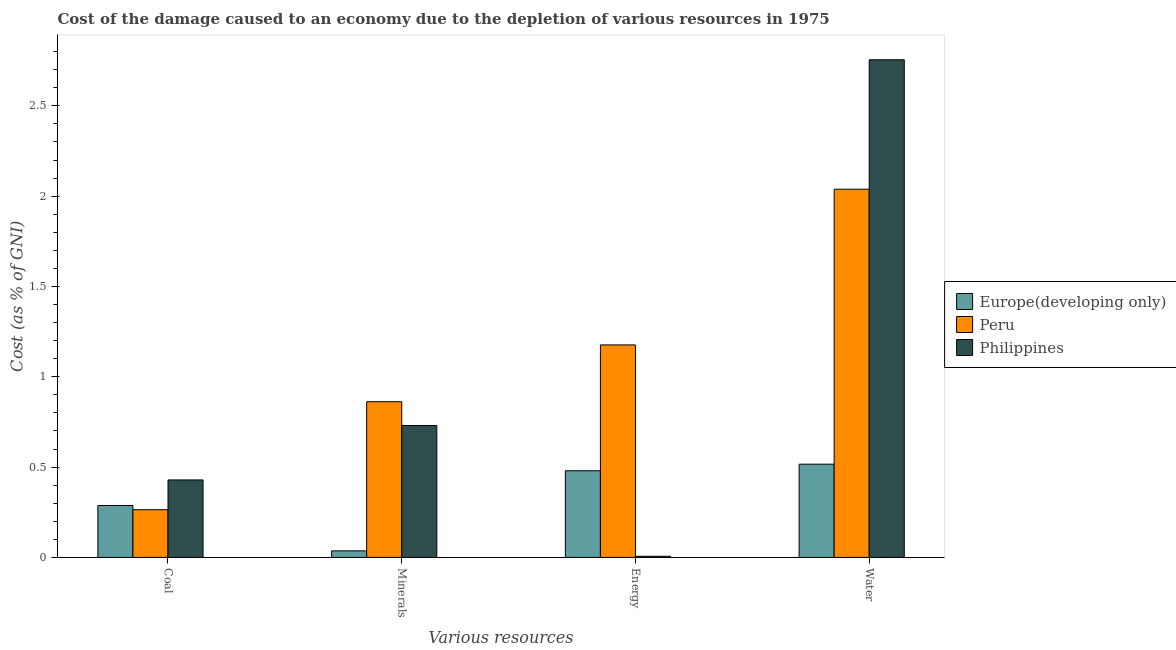How many different coloured bars are there?
Make the answer very short. 3. How many groups of bars are there?
Offer a very short reply. 4. Are the number of bars per tick equal to the number of legend labels?
Your response must be concise. Yes. Are the number of bars on each tick of the X-axis equal?
Your answer should be very brief. Yes. How many bars are there on the 3rd tick from the left?
Provide a succinct answer. 3. How many bars are there on the 4th tick from the right?
Ensure brevity in your answer.  3. What is the label of the 1st group of bars from the left?
Keep it short and to the point. Coal. What is the cost of damage due to depletion of coal in Philippines?
Provide a succinct answer. 0.43. Across all countries, what is the maximum cost of damage due to depletion of coal?
Provide a short and direct response. 0.43. Across all countries, what is the minimum cost of damage due to depletion of coal?
Ensure brevity in your answer.  0.26. In which country was the cost of damage due to depletion of minerals maximum?
Your answer should be very brief. Peru. In which country was the cost of damage due to depletion of coal minimum?
Provide a succinct answer. Peru. What is the total cost of damage due to depletion of water in the graph?
Make the answer very short. 5.31. What is the difference between the cost of damage due to depletion of energy in Europe(developing only) and that in Philippines?
Ensure brevity in your answer.  0.47. What is the difference between the cost of damage due to depletion of energy in Philippines and the cost of damage due to depletion of minerals in Peru?
Give a very brief answer. -0.86. What is the average cost of damage due to depletion of water per country?
Make the answer very short. 1.77. What is the difference between the cost of damage due to depletion of energy and cost of damage due to depletion of minerals in Peru?
Your answer should be compact. 0.31. What is the ratio of the cost of damage due to depletion of energy in Peru to that in Philippines?
Ensure brevity in your answer.  183.58. Is the difference between the cost of damage due to depletion of minerals in Peru and Philippines greater than the difference between the cost of damage due to depletion of energy in Peru and Philippines?
Your response must be concise. No. What is the difference between the highest and the second highest cost of damage due to depletion of coal?
Your answer should be very brief. 0.14. What is the difference between the highest and the lowest cost of damage due to depletion of water?
Make the answer very short. 2.24. In how many countries, is the cost of damage due to depletion of minerals greater than the average cost of damage due to depletion of minerals taken over all countries?
Offer a very short reply. 2. Is the sum of the cost of damage due to depletion of energy in Philippines and Peru greater than the maximum cost of damage due to depletion of coal across all countries?
Make the answer very short. Yes. What does the 1st bar from the left in Coal represents?
Offer a very short reply. Europe(developing only). What does the 2nd bar from the right in Water represents?
Your answer should be compact. Peru. Is it the case that in every country, the sum of the cost of damage due to depletion of coal and cost of damage due to depletion of minerals is greater than the cost of damage due to depletion of energy?
Ensure brevity in your answer.  No. Are all the bars in the graph horizontal?
Your answer should be compact. No. What is the difference between two consecutive major ticks on the Y-axis?
Keep it short and to the point. 0.5. Are the values on the major ticks of Y-axis written in scientific E-notation?
Your answer should be very brief. No. How are the legend labels stacked?
Keep it short and to the point. Vertical. What is the title of the graph?
Make the answer very short. Cost of the damage caused to an economy due to the depletion of various resources in 1975 . Does "Isle of Man" appear as one of the legend labels in the graph?
Keep it short and to the point. No. What is the label or title of the X-axis?
Keep it short and to the point. Various resources. What is the label or title of the Y-axis?
Your response must be concise. Cost (as % of GNI). What is the Cost (as % of GNI) of Europe(developing only) in Coal?
Give a very brief answer. 0.29. What is the Cost (as % of GNI) in Peru in Coal?
Your response must be concise. 0.26. What is the Cost (as % of GNI) in Philippines in Coal?
Make the answer very short. 0.43. What is the Cost (as % of GNI) of Europe(developing only) in Minerals?
Offer a terse response. 0.04. What is the Cost (as % of GNI) of Peru in Minerals?
Ensure brevity in your answer.  0.86. What is the Cost (as % of GNI) in Philippines in Minerals?
Provide a succinct answer. 0.73. What is the Cost (as % of GNI) of Europe(developing only) in Energy?
Give a very brief answer. 0.48. What is the Cost (as % of GNI) in Peru in Energy?
Keep it short and to the point. 1.18. What is the Cost (as % of GNI) in Philippines in Energy?
Ensure brevity in your answer.  0.01. What is the Cost (as % of GNI) of Europe(developing only) in Water?
Offer a very short reply. 0.52. What is the Cost (as % of GNI) of Peru in Water?
Provide a short and direct response. 2.04. What is the Cost (as % of GNI) of Philippines in Water?
Offer a terse response. 2.75. Across all Various resources, what is the maximum Cost (as % of GNI) in Europe(developing only)?
Your answer should be compact. 0.52. Across all Various resources, what is the maximum Cost (as % of GNI) in Peru?
Keep it short and to the point. 2.04. Across all Various resources, what is the maximum Cost (as % of GNI) in Philippines?
Offer a terse response. 2.75. Across all Various resources, what is the minimum Cost (as % of GNI) of Europe(developing only)?
Give a very brief answer. 0.04. Across all Various resources, what is the minimum Cost (as % of GNI) in Peru?
Keep it short and to the point. 0.26. Across all Various resources, what is the minimum Cost (as % of GNI) in Philippines?
Offer a very short reply. 0.01. What is the total Cost (as % of GNI) of Europe(developing only) in the graph?
Ensure brevity in your answer.  1.32. What is the total Cost (as % of GNI) in Peru in the graph?
Offer a very short reply. 4.34. What is the total Cost (as % of GNI) of Philippines in the graph?
Provide a succinct answer. 3.92. What is the difference between the Cost (as % of GNI) in Europe(developing only) in Coal and that in Minerals?
Your answer should be compact. 0.25. What is the difference between the Cost (as % of GNI) in Peru in Coal and that in Minerals?
Provide a succinct answer. -0.6. What is the difference between the Cost (as % of GNI) in Philippines in Coal and that in Minerals?
Provide a succinct answer. -0.3. What is the difference between the Cost (as % of GNI) in Europe(developing only) in Coal and that in Energy?
Give a very brief answer. -0.19. What is the difference between the Cost (as % of GNI) of Peru in Coal and that in Energy?
Your answer should be very brief. -0.91. What is the difference between the Cost (as % of GNI) in Philippines in Coal and that in Energy?
Offer a very short reply. 0.42. What is the difference between the Cost (as % of GNI) in Europe(developing only) in Coal and that in Water?
Your answer should be very brief. -0.23. What is the difference between the Cost (as % of GNI) in Peru in Coal and that in Water?
Your answer should be compact. -1.77. What is the difference between the Cost (as % of GNI) of Philippines in Coal and that in Water?
Make the answer very short. -2.33. What is the difference between the Cost (as % of GNI) of Europe(developing only) in Minerals and that in Energy?
Offer a terse response. -0.44. What is the difference between the Cost (as % of GNI) in Peru in Minerals and that in Energy?
Your answer should be very brief. -0.31. What is the difference between the Cost (as % of GNI) of Philippines in Minerals and that in Energy?
Your answer should be very brief. 0.72. What is the difference between the Cost (as % of GNI) in Europe(developing only) in Minerals and that in Water?
Your response must be concise. -0.48. What is the difference between the Cost (as % of GNI) in Peru in Minerals and that in Water?
Ensure brevity in your answer.  -1.18. What is the difference between the Cost (as % of GNI) in Philippines in Minerals and that in Water?
Your answer should be compact. -2.02. What is the difference between the Cost (as % of GNI) in Europe(developing only) in Energy and that in Water?
Offer a very short reply. -0.04. What is the difference between the Cost (as % of GNI) of Peru in Energy and that in Water?
Your answer should be very brief. -0.86. What is the difference between the Cost (as % of GNI) of Philippines in Energy and that in Water?
Your response must be concise. -2.75. What is the difference between the Cost (as % of GNI) of Europe(developing only) in Coal and the Cost (as % of GNI) of Peru in Minerals?
Your answer should be very brief. -0.57. What is the difference between the Cost (as % of GNI) in Europe(developing only) in Coal and the Cost (as % of GNI) in Philippines in Minerals?
Make the answer very short. -0.44. What is the difference between the Cost (as % of GNI) of Peru in Coal and the Cost (as % of GNI) of Philippines in Minerals?
Make the answer very short. -0.47. What is the difference between the Cost (as % of GNI) of Europe(developing only) in Coal and the Cost (as % of GNI) of Peru in Energy?
Your answer should be compact. -0.89. What is the difference between the Cost (as % of GNI) of Europe(developing only) in Coal and the Cost (as % of GNI) of Philippines in Energy?
Give a very brief answer. 0.28. What is the difference between the Cost (as % of GNI) of Peru in Coal and the Cost (as % of GNI) of Philippines in Energy?
Your response must be concise. 0.26. What is the difference between the Cost (as % of GNI) of Europe(developing only) in Coal and the Cost (as % of GNI) of Peru in Water?
Make the answer very short. -1.75. What is the difference between the Cost (as % of GNI) of Europe(developing only) in Coal and the Cost (as % of GNI) of Philippines in Water?
Ensure brevity in your answer.  -2.47. What is the difference between the Cost (as % of GNI) of Peru in Coal and the Cost (as % of GNI) of Philippines in Water?
Your response must be concise. -2.49. What is the difference between the Cost (as % of GNI) of Europe(developing only) in Minerals and the Cost (as % of GNI) of Peru in Energy?
Keep it short and to the point. -1.14. What is the difference between the Cost (as % of GNI) of Peru in Minerals and the Cost (as % of GNI) of Philippines in Energy?
Provide a short and direct response. 0.86. What is the difference between the Cost (as % of GNI) of Europe(developing only) in Minerals and the Cost (as % of GNI) of Peru in Water?
Give a very brief answer. -2. What is the difference between the Cost (as % of GNI) of Europe(developing only) in Minerals and the Cost (as % of GNI) of Philippines in Water?
Ensure brevity in your answer.  -2.72. What is the difference between the Cost (as % of GNI) in Peru in Minerals and the Cost (as % of GNI) in Philippines in Water?
Ensure brevity in your answer.  -1.89. What is the difference between the Cost (as % of GNI) of Europe(developing only) in Energy and the Cost (as % of GNI) of Peru in Water?
Your answer should be compact. -1.56. What is the difference between the Cost (as % of GNI) of Europe(developing only) in Energy and the Cost (as % of GNI) of Philippines in Water?
Your response must be concise. -2.28. What is the difference between the Cost (as % of GNI) of Peru in Energy and the Cost (as % of GNI) of Philippines in Water?
Give a very brief answer. -1.58. What is the average Cost (as % of GNI) of Europe(developing only) per Various resources?
Ensure brevity in your answer.  0.33. What is the average Cost (as % of GNI) of Peru per Various resources?
Ensure brevity in your answer.  1.09. What is the average Cost (as % of GNI) of Philippines per Various resources?
Provide a succinct answer. 0.98. What is the difference between the Cost (as % of GNI) of Europe(developing only) and Cost (as % of GNI) of Peru in Coal?
Your answer should be very brief. 0.02. What is the difference between the Cost (as % of GNI) in Europe(developing only) and Cost (as % of GNI) in Philippines in Coal?
Offer a very short reply. -0.14. What is the difference between the Cost (as % of GNI) of Peru and Cost (as % of GNI) of Philippines in Coal?
Offer a very short reply. -0.16. What is the difference between the Cost (as % of GNI) in Europe(developing only) and Cost (as % of GNI) in Peru in Minerals?
Ensure brevity in your answer.  -0.83. What is the difference between the Cost (as % of GNI) in Europe(developing only) and Cost (as % of GNI) in Philippines in Minerals?
Your answer should be compact. -0.69. What is the difference between the Cost (as % of GNI) of Peru and Cost (as % of GNI) of Philippines in Minerals?
Make the answer very short. 0.13. What is the difference between the Cost (as % of GNI) in Europe(developing only) and Cost (as % of GNI) in Peru in Energy?
Provide a short and direct response. -0.7. What is the difference between the Cost (as % of GNI) in Europe(developing only) and Cost (as % of GNI) in Philippines in Energy?
Provide a succinct answer. 0.47. What is the difference between the Cost (as % of GNI) in Peru and Cost (as % of GNI) in Philippines in Energy?
Provide a succinct answer. 1.17. What is the difference between the Cost (as % of GNI) in Europe(developing only) and Cost (as % of GNI) in Peru in Water?
Offer a very short reply. -1.52. What is the difference between the Cost (as % of GNI) of Europe(developing only) and Cost (as % of GNI) of Philippines in Water?
Make the answer very short. -2.24. What is the difference between the Cost (as % of GNI) in Peru and Cost (as % of GNI) in Philippines in Water?
Give a very brief answer. -0.72. What is the ratio of the Cost (as % of GNI) of Europe(developing only) in Coal to that in Minerals?
Offer a very short reply. 7.9. What is the ratio of the Cost (as % of GNI) of Peru in Coal to that in Minerals?
Provide a succinct answer. 0.31. What is the ratio of the Cost (as % of GNI) of Philippines in Coal to that in Minerals?
Provide a short and direct response. 0.59. What is the ratio of the Cost (as % of GNI) in Europe(developing only) in Coal to that in Energy?
Offer a terse response. 0.6. What is the ratio of the Cost (as % of GNI) of Peru in Coal to that in Energy?
Ensure brevity in your answer.  0.22. What is the ratio of the Cost (as % of GNI) of Philippines in Coal to that in Energy?
Your answer should be compact. 66.95. What is the ratio of the Cost (as % of GNI) of Europe(developing only) in Coal to that in Water?
Keep it short and to the point. 0.56. What is the ratio of the Cost (as % of GNI) in Peru in Coal to that in Water?
Keep it short and to the point. 0.13. What is the ratio of the Cost (as % of GNI) in Philippines in Coal to that in Water?
Offer a very short reply. 0.16. What is the ratio of the Cost (as % of GNI) of Europe(developing only) in Minerals to that in Energy?
Your answer should be very brief. 0.08. What is the ratio of the Cost (as % of GNI) in Peru in Minerals to that in Energy?
Give a very brief answer. 0.73. What is the ratio of the Cost (as % of GNI) in Philippines in Minerals to that in Energy?
Your response must be concise. 113.98. What is the ratio of the Cost (as % of GNI) of Europe(developing only) in Minerals to that in Water?
Make the answer very short. 0.07. What is the ratio of the Cost (as % of GNI) in Peru in Minerals to that in Water?
Make the answer very short. 0.42. What is the ratio of the Cost (as % of GNI) of Philippines in Minerals to that in Water?
Offer a very short reply. 0.27. What is the ratio of the Cost (as % of GNI) in Europe(developing only) in Energy to that in Water?
Offer a terse response. 0.93. What is the ratio of the Cost (as % of GNI) of Peru in Energy to that in Water?
Give a very brief answer. 0.58. What is the ratio of the Cost (as % of GNI) in Philippines in Energy to that in Water?
Ensure brevity in your answer.  0. What is the difference between the highest and the second highest Cost (as % of GNI) of Europe(developing only)?
Ensure brevity in your answer.  0.04. What is the difference between the highest and the second highest Cost (as % of GNI) of Peru?
Provide a succinct answer. 0.86. What is the difference between the highest and the second highest Cost (as % of GNI) in Philippines?
Give a very brief answer. 2.02. What is the difference between the highest and the lowest Cost (as % of GNI) of Europe(developing only)?
Make the answer very short. 0.48. What is the difference between the highest and the lowest Cost (as % of GNI) in Peru?
Give a very brief answer. 1.77. What is the difference between the highest and the lowest Cost (as % of GNI) in Philippines?
Provide a short and direct response. 2.75. 